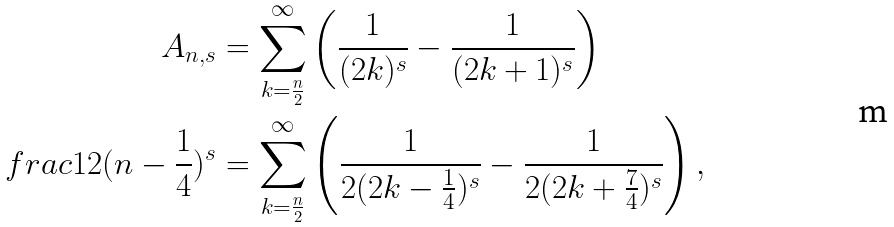<formula> <loc_0><loc_0><loc_500><loc_500>A _ { n , s } & = \sum _ { k = \frac { n } { 2 } } ^ { \infty } \left ( \frac { 1 } { ( 2 k ) ^ { s } } - \frac { 1 } { ( 2 k + 1 ) ^ { s } } \right ) \quad \\ f r a c { 1 } { 2 ( n - \frac { 1 } { 4 } ) ^ { s } } & = \sum _ { k = \frac { n } { 2 } } ^ { \infty } \left ( \frac { 1 } { 2 ( 2 k - \frac { 1 } { 4 } ) ^ { s } } - \frac { 1 } { 2 ( 2 k + \frac { 7 } { 4 } ) ^ { s } } \right ) ,</formula> 